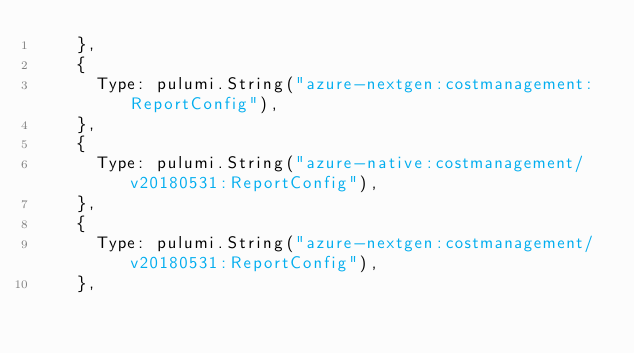<code> <loc_0><loc_0><loc_500><loc_500><_Go_>		},
		{
			Type: pulumi.String("azure-nextgen:costmanagement:ReportConfig"),
		},
		{
			Type: pulumi.String("azure-native:costmanagement/v20180531:ReportConfig"),
		},
		{
			Type: pulumi.String("azure-nextgen:costmanagement/v20180531:ReportConfig"),
		},</code> 